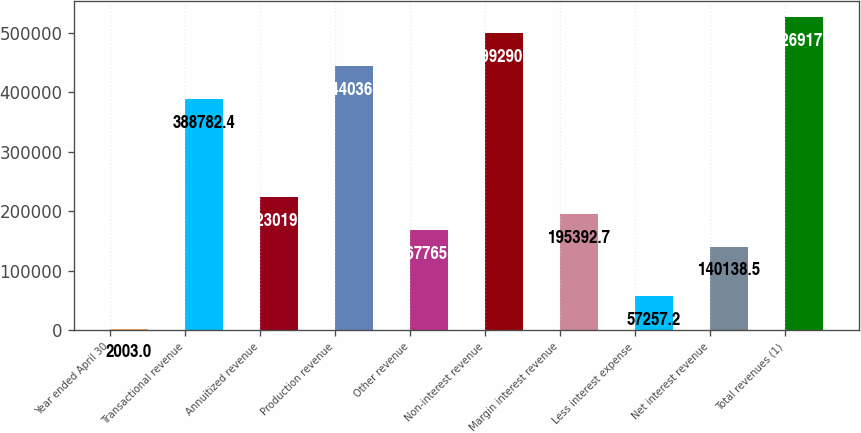Convert chart. <chart><loc_0><loc_0><loc_500><loc_500><bar_chart><fcel>Year ended April 30<fcel>Transactional revenue<fcel>Annuitized revenue<fcel>Production revenue<fcel>Other revenue<fcel>Non-interest revenue<fcel>Margin interest revenue<fcel>Less interest expense<fcel>Net interest revenue<fcel>Total revenues (1)<nl><fcel>2003<fcel>388782<fcel>223020<fcel>444037<fcel>167766<fcel>499291<fcel>195393<fcel>57257.2<fcel>140138<fcel>526918<nl></chart> 